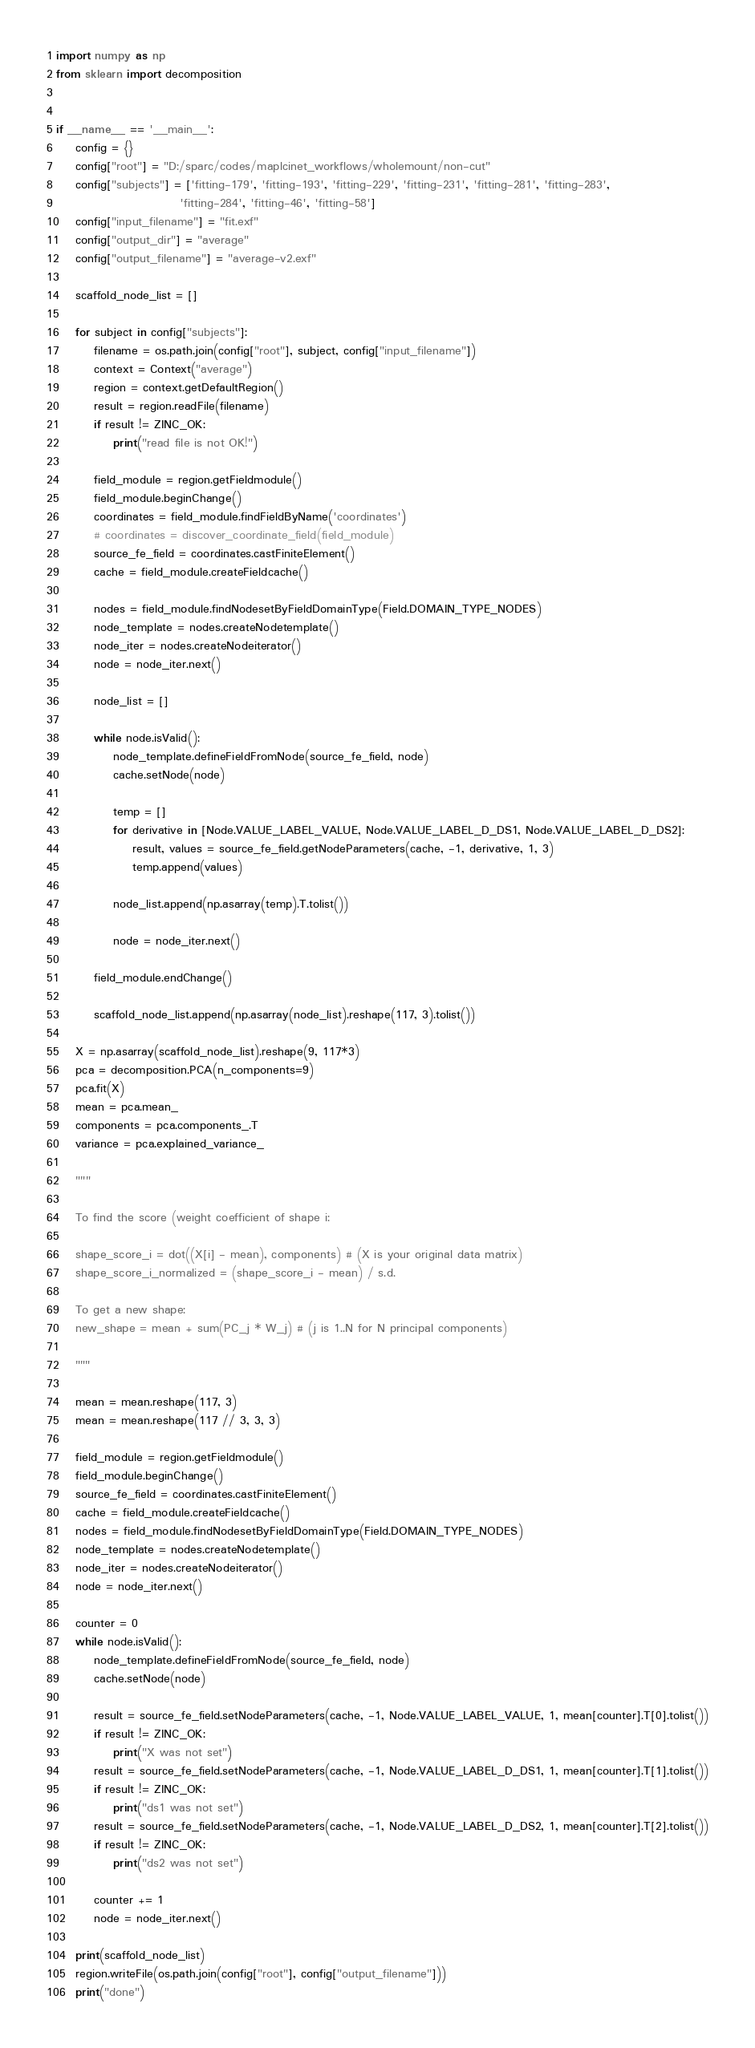Convert code to text. <code><loc_0><loc_0><loc_500><loc_500><_Python_>import numpy as np
from sklearn import decomposition


if __name__ == '__main__':
    config = {}
    config["root"] = "D:/sparc/codes/maplcinet_workflows/wholemount/non-cut"
    config["subjects"] = ['fitting-179', 'fitting-193', 'fitting-229', 'fitting-231', 'fitting-281', 'fitting-283',
                          'fitting-284', 'fitting-46', 'fitting-58']
    config["input_filename"] = "fit.exf"
    config["output_dir"] = "average"
    config["output_filename"] = "average-v2.exf"

    scaffold_node_list = []

    for subject in config["subjects"]:
        filename = os.path.join(config["root"], subject, config["input_filename"])
        context = Context("average")
        region = context.getDefaultRegion()
        result = region.readFile(filename)
        if result != ZINC_OK:
            print("read file is not OK!")

        field_module = region.getFieldmodule()
        field_module.beginChange()
        coordinates = field_module.findFieldByName('coordinates')
        # coordinates = discover_coordinate_field(field_module)
        source_fe_field = coordinates.castFiniteElement()
        cache = field_module.createFieldcache()

        nodes = field_module.findNodesetByFieldDomainType(Field.DOMAIN_TYPE_NODES)
        node_template = nodes.createNodetemplate()
        node_iter = nodes.createNodeiterator()
        node = node_iter.next()

        node_list = []

        while node.isValid():
            node_template.defineFieldFromNode(source_fe_field, node)
            cache.setNode(node)

            temp = []
            for derivative in [Node.VALUE_LABEL_VALUE, Node.VALUE_LABEL_D_DS1, Node.VALUE_LABEL_D_DS2]:
                result, values = source_fe_field.getNodeParameters(cache, -1, derivative, 1, 3)
                temp.append(values)

            node_list.append(np.asarray(temp).T.tolist())

            node = node_iter.next()

        field_module.endChange()

        scaffold_node_list.append(np.asarray(node_list).reshape(117, 3).tolist())

    X = np.asarray(scaffold_node_list).reshape(9, 117*3)
    pca = decomposition.PCA(n_components=9)
    pca.fit(X)
    mean = pca.mean_
    components = pca.components_.T
    variance = pca.explained_variance_

    """
    
    To find the score (weight coefficient of shape i:
    
    shape_score_i = dot((X[i] - mean), components) # (X is your original data matrix)
    shape_score_i_normalized = (shape_score_i - mean) / s.d.
    
    To get a new shape:
    new_shape = mean + sum(PC_j * W_j) # (j is 1..N for N principal components)
    
    """

    mean = mean.reshape(117, 3)
    mean = mean.reshape(117 // 3, 3, 3)

    field_module = region.getFieldmodule()
    field_module.beginChange()
    source_fe_field = coordinates.castFiniteElement()
    cache = field_module.createFieldcache()
    nodes = field_module.findNodesetByFieldDomainType(Field.DOMAIN_TYPE_NODES)
    node_template = nodes.createNodetemplate()
    node_iter = nodes.createNodeiterator()
    node = node_iter.next()

    counter = 0
    while node.isValid():
        node_template.defineFieldFromNode(source_fe_field, node)
        cache.setNode(node)

        result = source_fe_field.setNodeParameters(cache, -1, Node.VALUE_LABEL_VALUE, 1, mean[counter].T[0].tolist())
        if result != ZINC_OK:
            print("X was not set")
        result = source_fe_field.setNodeParameters(cache, -1, Node.VALUE_LABEL_D_DS1, 1, mean[counter].T[1].tolist())
        if result != ZINC_OK:
            print("ds1 was not set")
        result = source_fe_field.setNodeParameters(cache, -1, Node.VALUE_LABEL_D_DS2, 1, mean[counter].T[2].tolist())
        if result != ZINC_OK:
            print("ds2 was not set")

        counter += 1
        node = node_iter.next()

    print(scaffold_node_list)
    region.writeFile(os.path.join(config["root"], config["output_filename"]))
    print("done")
</code> 